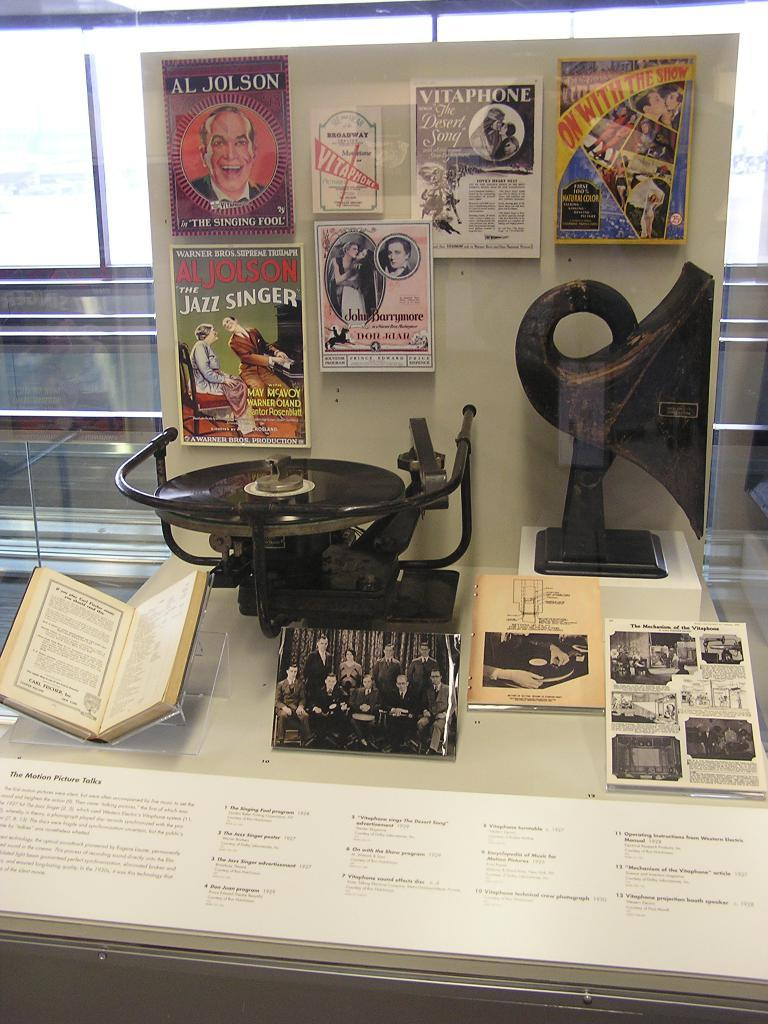<image>
Describe the image concisely. Posters hanging inside a screen with one that says Jazz Singer. 